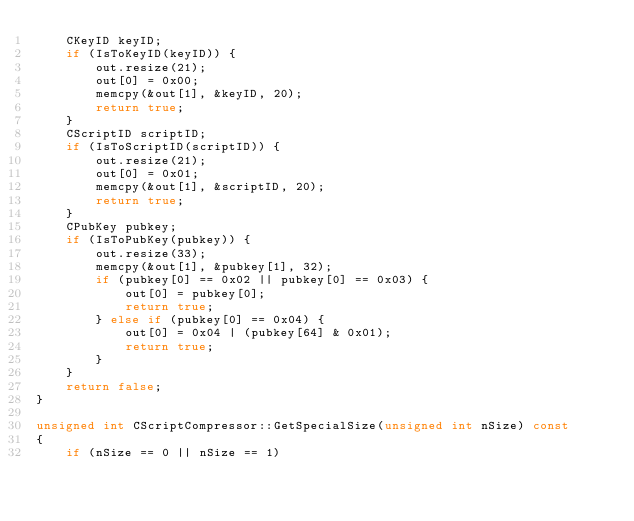<code> <loc_0><loc_0><loc_500><loc_500><_C++_>    CKeyID keyID;
    if (IsToKeyID(keyID)) {
        out.resize(21);
        out[0] = 0x00;
        memcpy(&out[1], &keyID, 20);
        return true;
    }
    CScriptID scriptID;
    if (IsToScriptID(scriptID)) {
        out.resize(21);
        out[0] = 0x01;
        memcpy(&out[1], &scriptID, 20);
        return true;
    }
    CPubKey pubkey;
    if (IsToPubKey(pubkey)) {
        out.resize(33);
        memcpy(&out[1], &pubkey[1], 32);
        if (pubkey[0] == 0x02 || pubkey[0] == 0x03) {
            out[0] = pubkey[0];
            return true;
        } else if (pubkey[0] == 0x04) {
            out[0] = 0x04 | (pubkey[64] & 0x01);
            return true;
        }
    }
    return false;
}

unsigned int CScriptCompressor::GetSpecialSize(unsigned int nSize) const
{
    if (nSize == 0 || nSize == 1)</code> 